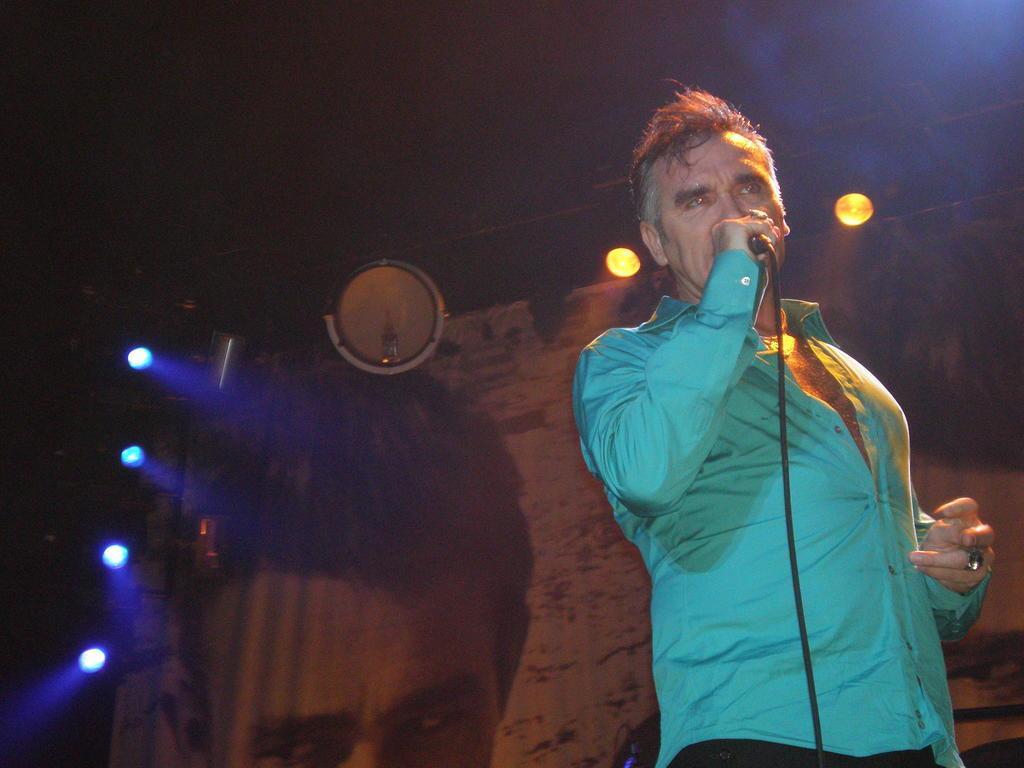Can you describe this image briefly? In this image I can see a person wearing a blue shirt is standing and holding a microphone in his hand. In the background I can see few lights, a banner and the dark sky. 